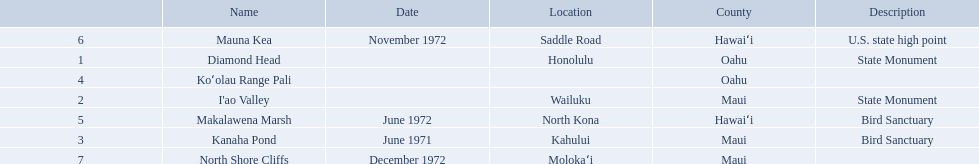What are all the landmark names? Diamond Head, I'ao Valley, Kanaha Pond, Koʻolau Range Pali, Makalawena Marsh, Mauna Kea, North Shore Cliffs. Which county is each landlord in? Oahu, Maui, Maui, Oahu, Hawaiʻi, Hawaiʻi, Maui. Along with mauna kea, which landmark is in hawai'i county? Makalawena Marsh. What are the names of the different hawaiian national landmarks Diamond Head, I'ao Valley, Kanaha Pond, Koʻolau Range Pali, Makalawena Marsh, Mauna Kea, North Shore Cliffs. Which landmark does not have a location listed? Koʻolau Range Pali. 